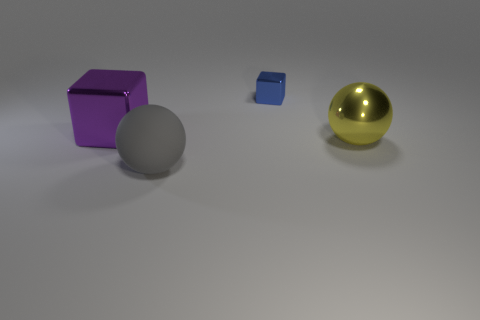Is the shape of the big object that is in front of the metallic sphere the same as the large metal object that is in front of the large purple block?
Give a very brief answer. Yes. There is a gray rubber object; is it the same size as the metallic block to the right of the big matte thing?
Your response must be concise. No. What shape is the thing that is both behind the big metallic sphere and on the left side of the tiny shiny thing?
Your answer should be very brief. Cube. Are there any large shiny things that have the same shape as the gray rubber object?
Your answer should be very brief. Yes. Is the size of the block behind the big purple metal thing the same as the shiny object that is on the left side of the large gray matte sphere?
Provide a short and direct response. No. Is the number of big purple metal cubes greater than the number of large red balls?
Keep it short and to the point. Yes. What number of large purple cubes have the same material as the tiny object?
Provide a short and direct response. 1. Do the tiny blue metal thing and the purple metallic thing have the same shape?
Provide a succinct answer. Yes. There is a blue thing that is behind the metal thing that is in front of the large metal object left of the gray ball; what size is it?
Provide a short and direct response. Small. There is a cube that is right of the purple thing; is there a blue cube in front of it?
Provide a short and direct response. No. 